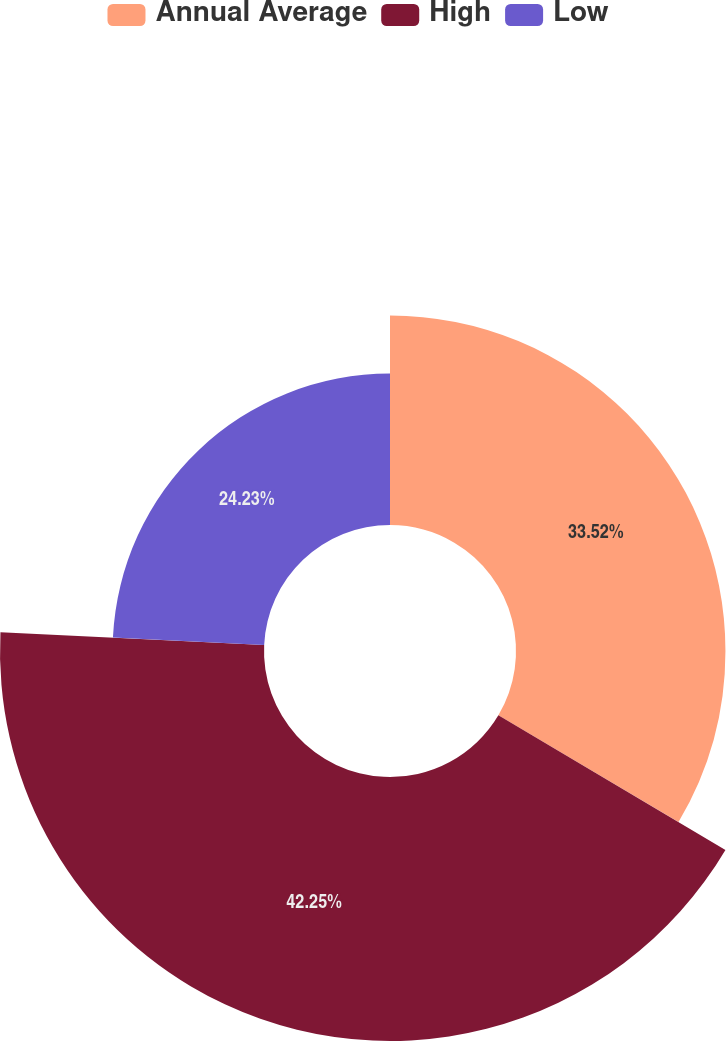<chart> <loc_0><loc_0><loc_500><loc_500><pie_chart><fcel>Annual Average<fcel>High<fcel>Low<nl><fcel>33.52%<fcel>42.25%<fcel>24.23%<nl></chart> 